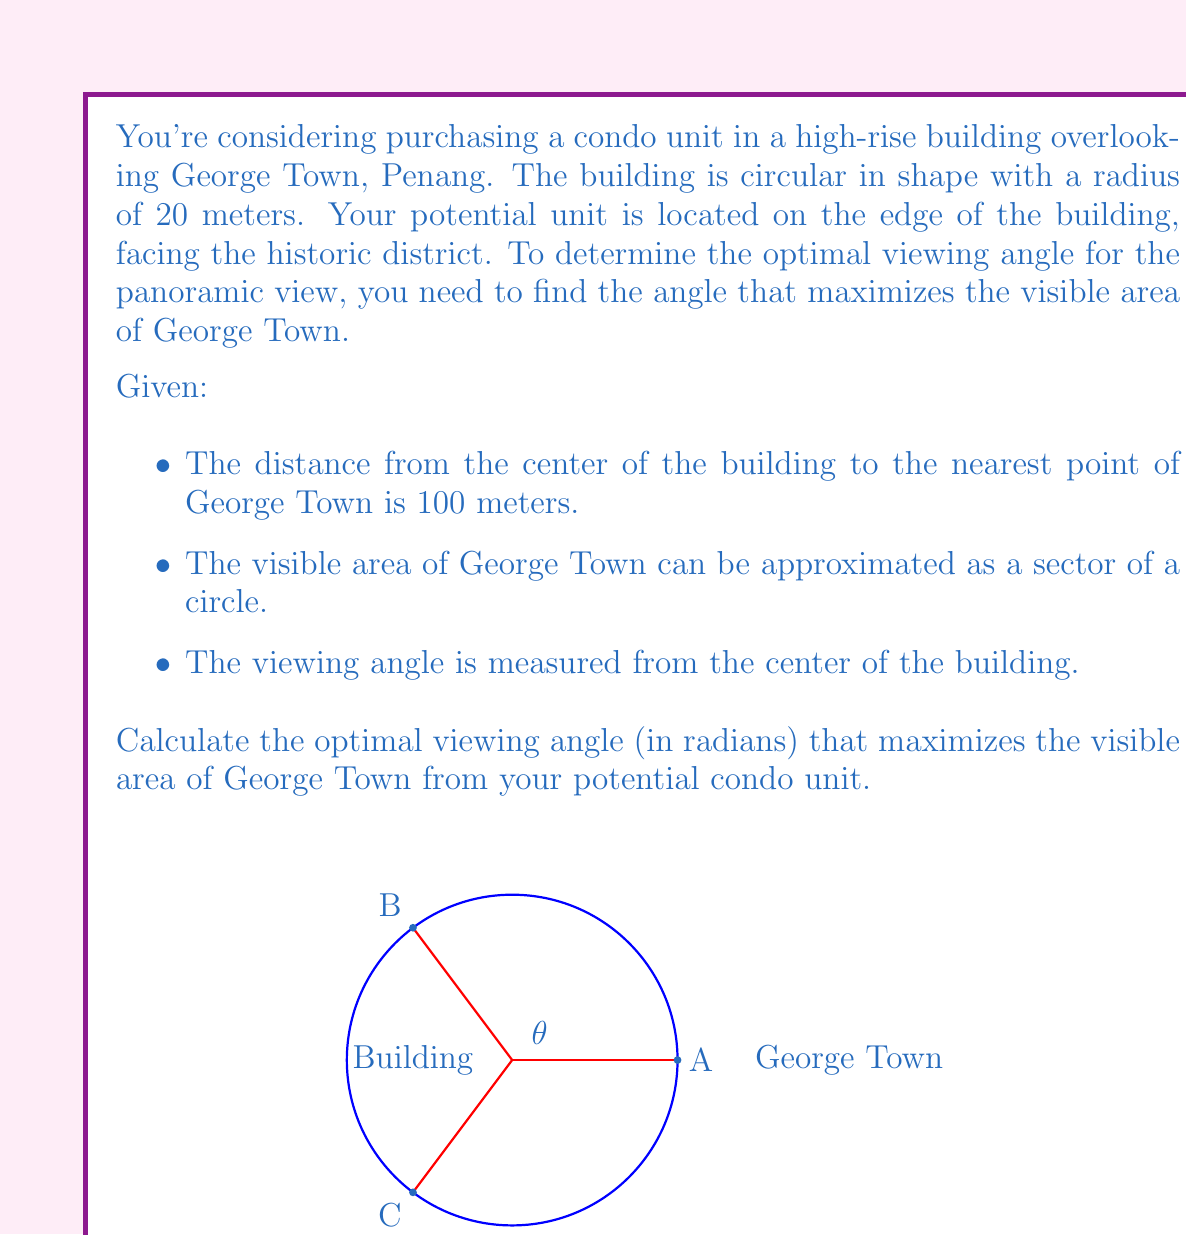Show me your answer to this math problem. Let's approach this step-by-step:

1) Let $\theta$ be the viewing angle we're trying to optimize. The visible area of George Town can be represented as a sector of a circle with radius $R$ and angle $\theta$.

2) The area of this sector is given by:

   $$A = \frac{1}{2}R^2\theta$$

3) We need to express $R$ in terms of $\theta$. Using the law of cosines in the triangle formed by the center of the building, the edge of the building, and the nearest point of George Town:

   $$R^2 = 100^2 + 20^2 - 2(100)(20)\cos(\frac{\theta}{2})$$

4) Substituting this into our area formula:

   $$A = \frac{1}{2}\theta(10000 + 400 - 4000\cos(\frac{\theta}{2}))$$

5) To find the maximum, we differentiate $A$ with respect to $\theta$ and set it to zero:

   $$\frac{dA}{d\theta} = \frac{1}{2}(10400 - 4000\cos(\frac{\theta}{2})) + \frac{1}{2}\theta(2000\sin(\frac{\theta}{2}))(\frac{1}{2}) = 0$$

6) Simplifying:

   $$10400 - 4000\cos(\frac{\theta}{2}) + 500\theta\sin(\frac{\theta}{2}) = 0$$

7) This equation can't be solved algebraically. We need to use numerical methods to find that the optimal angle is approximately 2.41 radians or 138 degrees.

8) To verify this is a maximum, we can check the second derivative is negative at this point.
Answer: $\theta \approx 2.41$ radians 